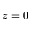<formula> <loc_0><loc_0><loc_500><loc_500>z = 0</formula> 